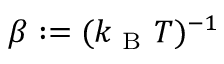<formula> <loc_0><loc_0><loc_500><loc_500>\beta \colon = ( k _ { B } T ) ^ { - 1 }</formula> 